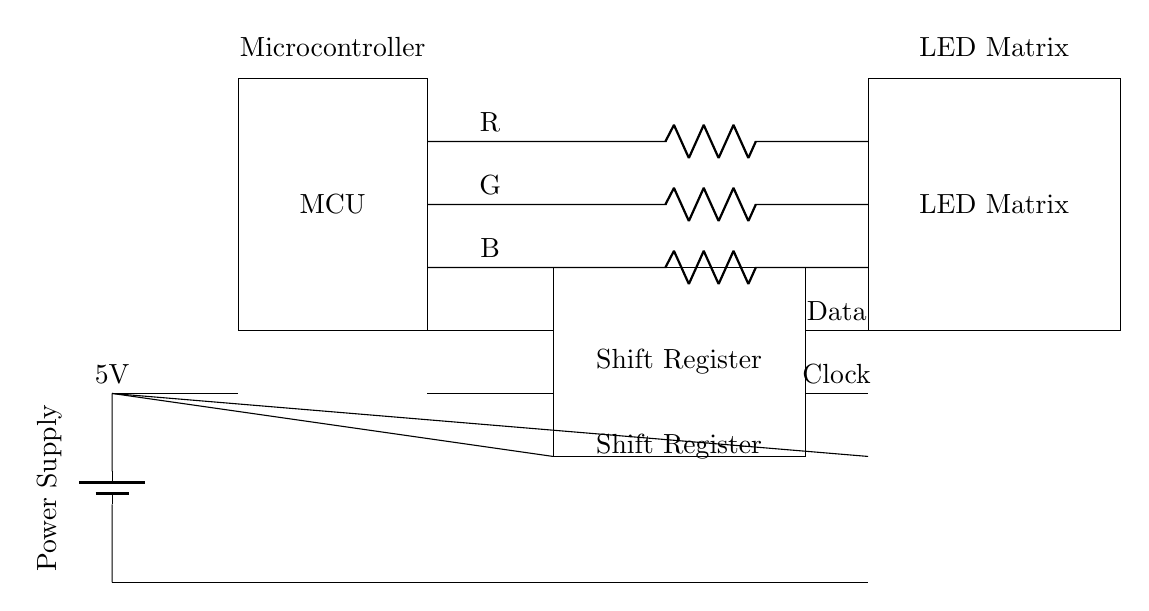What is the power supply voltage for this circuit? The circuit contains a power supply component represented by a battery symbol, which shows the voltage is specified right next to it as 5V.
Answer: 5V What components are connected to the microcontroller? The microcontroller is connected to three components: the shift register via data and clock connections, and power connections to the battery. Each connection shows a pathway that links these components together for operation.
Answer: Shift Register, Power Supply How many connections are there from the shift register to the LED matrix? The shift register connects to the LED matrix via four distinct connections labeled as data, clock, and three colored R, G, and B lines which facilitate the transmission of color signals. This indicates a total of four individual connection points.
Answer: Four What is the purpose of the shift register in this circuit? The shift register serves to convert parallel input from the microcontroller into a serial output that can be transported to the LED matrix, enabling control over multiple LEDs in a controlled manner, essential for dynamic lighting.
Answer: Control LED signals What is transmitted along the data line from the shift register to the LED matrix? The data line carries the digital signals that determine which LEDs light up and what color they are, allowing for real-time control of the matrix's illumination based on input received by the microcontroller.
Answer: Digital signals What color signals are represented in this circuit? The circuit diagram shows three color signals interfacing between the microcontroller and the LED matrix, specifically labeled R, G, and B, which represent red, green, and blue light components, respectively, forming various color combinations.
Answer: Red, Green, Blue 